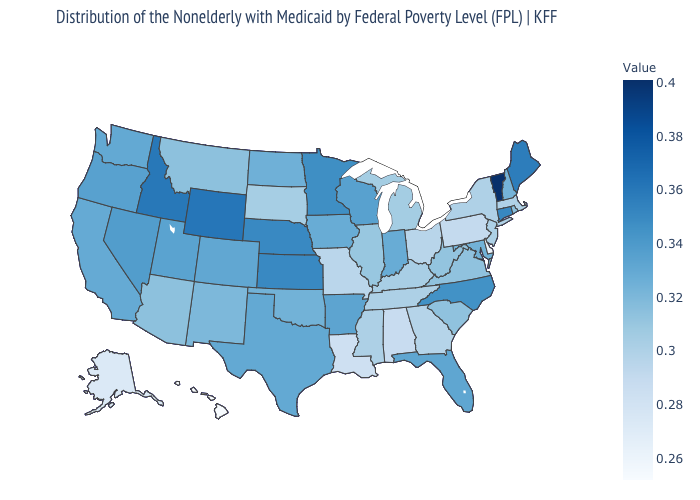Which states hav the highest value in the MidWest?
Quick response, please. Kansas, Nebraska. Among the states that border Nevada , which have the lowest value?
Write a very short answer. Arizona. Does Nebraska have the highest value in the USA?
Keep it brief. No. Which states have the highest value in the USA?
Keep it brief. Vermont. Does the map have missing data?
Answer briefly. No. Does Hawaii have the lowest value in the West?
Quick response, please. Yes. 